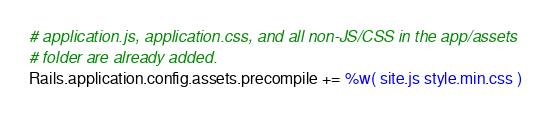<code> <loc_0><loc_0><loc_500><loc_500><_Ruby_># application.js, application.css, and all non-JS/CSS in the app/assets
# folder are already added.
Rails.application.config.assets.precompile += %w( site.js style.min.css )
</code> 